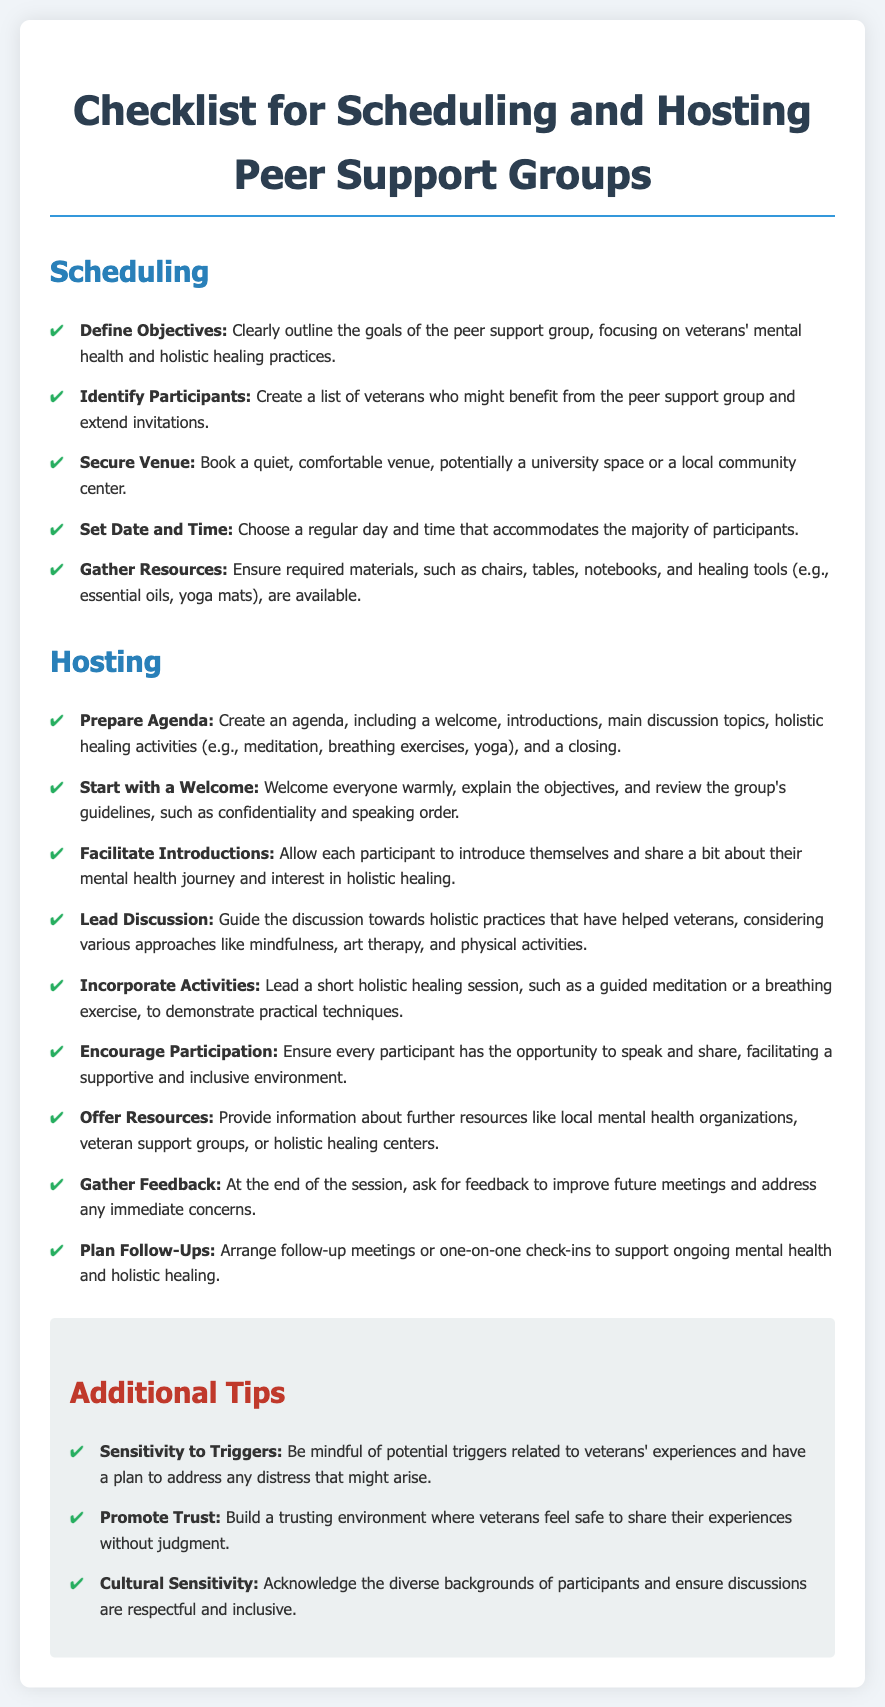what is the title of the document? The title is prominently displayed at the top of the document, indicating the subject matter clearly.
Answer: Checklist for Scheduling and Hosting Peer Support Groups how many main sections are in the document? There are two main sections highlighted in the document for organizing the information effectively.
Answer: 2 what is the first step in scheduling a peer support group? The first step is listed at the beginning of the Scheduling section, emphasizing its importance in the process.
Answer: Define Objectives which activity is suggested to start the peer support group? The document outlines this as an essential way to create a welcoming atmosphere during the meeting.
Answer: Start with a Welcome what holistic healing activity is mentioned for incorporation during hosting? This activity is proposed in the Hosting section to enhance participants' experience and engagement.
Answer: Guided meditation what kind of feedback is recommended at the end of the session? The type of feedback suggested focuses on improving future meetings and addressing concerns.
Answer: Gather Feedback what is one of the additional tips provided? This tip aims to create a supportive environment for veterans during the meetings.
Answer: Sensitivity to Triggers how should the introductions be facilitated? It describes a way to allow each participant to share their experiences in a respectful manner.
Answer: Facilitate Introductions 